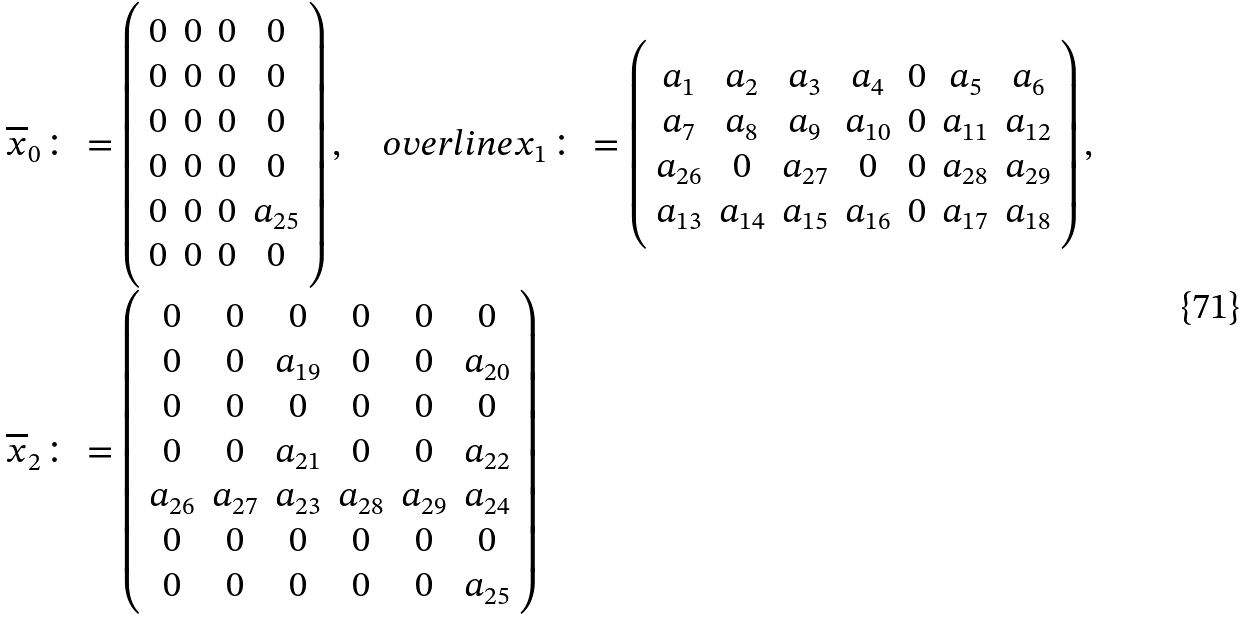Convert formula to latex. <formula><loc_0><loc_0><loc_500><loc_500>\overline { x } _ { 0 } & \colon = \left ( \begin{array} { c c c c } 0 & 0 & 0 & 0 \\ 0 & 0 & 0 & 0 \\ 0 & 0 & 0 & 0 \\ 0 & 0 & 0 & 0 \\ 0 & 0 & 0 & a _ { 2 5 } \\ 0 & 0 & 0 & 0 \\ \end{array} \right ) , \quad o v e r l i n e { x } _ { 1 } \colon = \left ( \begin{array} { c c c c c c c } a _ { 1 } & a _ { 2 } & a _ { 3 } & a _ { 4 } & 0 & a _ { 5 } & a _ { 6 } \\ a _ { 7 } & a _ { 8 } & a _ { 9 } & a _ { 1 0 } & 0 & a _ { 1 1 } & a _ { 1 2 } \\ a _ { 2 6 } & 0 & a _ { 2 7 } & 0 & 0 & a _ { 2 8 } & a _ { 2 9 } \\ a _ { 1 3 } & a _ { 1 4 } & a _ { 1 5 } & a _ { 1 6 } & 0 & a _ { 1 7 } & a _ { 1 8 } \\ \end{array} \right ) , \\ \overline { x } _ { 2 } & \colon = \left ( \begin{array} { c c c c c c } 0 & 0 & 0 & 0 & 0 & 0 \\ 0 & 0 & a _ { 1 9 } & 0 & 0 & a _ { 2 0 } \\ 0 & 0 & 0 & 0 & 0 & 0 \\ 0 & 0 & a _ { 2 1 } & 0 & 0 & a _ { 2 2 } \\ a _ { 2 6 } & a _ { 2 7 } & a _ { 2 3 } & a _ { 2 8 } & a _ { 2 9 } & a _ { 2 4 } \\ 0 & 0 & 0 & 0 & 0 & 0 \\ 0 & 0 & 0 & 0 & 0 & a _ { 2 5 } \\ \end{array} \right )</formula> 